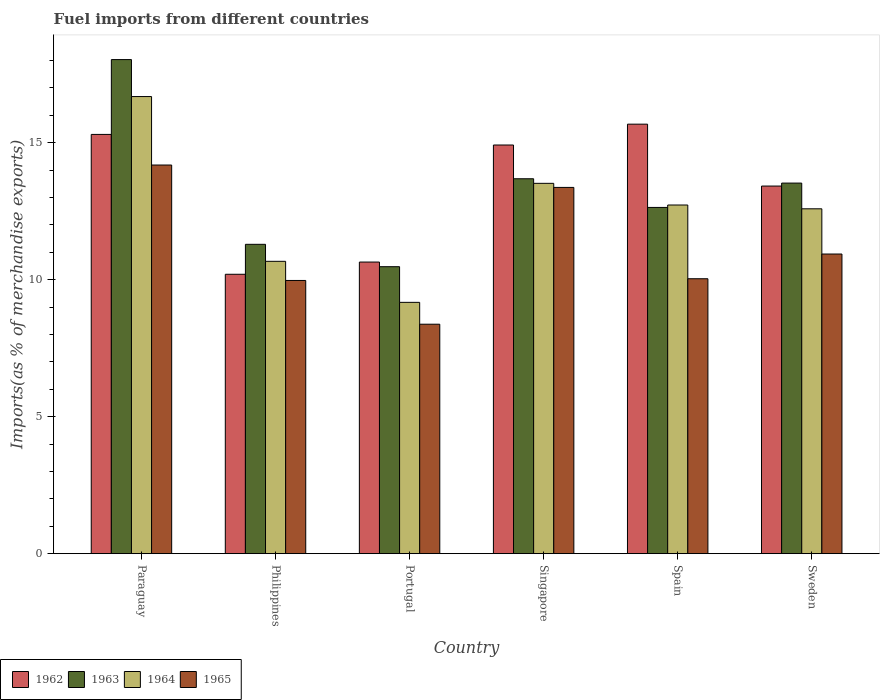How many different coloured bars are there?
Provide a succinct answer. 4. How many groups of bars are there?
Keep it short and to the point. 6. Are the number of bars per tick equal to the number of legend labels?
Provide a short and direct response. Yes. Are the number of bars on each tick of the X-axis equal?
Keep it short and to the point. Yes. How many bars are there on the 1st tick from the right?
Provide a short and direct response. 4. What is the percentage of imports to different countries in 1964 in Paraguay?
Your answer should be very brief. 16.68. Across all countries, what is the maximum percentage of imports to different countries in 1963?
Provide a succinct answer. 18.03. Across all countries, what is the minimum percentage of imports to different countries in 1964?
Provide a short and direct response. 9.17. What is the total percentage of imports to different countries in 1963 in the graph?
Ensure brevity in your answer.  79.63. What is the difference between the percentage of imports to different countries in 1962 in Spain and that in Sweden?
Provide a succinct answer. 2.26. What is the difference between the percentage of imports to different countries in 1962 in Sweden and the percentage of imports to different countries in 1964 in Portugal?
Make the answer very short. 4.24. What is the average percentage of imports to different countries in 1965 per country?
Your response must be concise. 11.14. What is the difference between the percentage of imports to different countries of/in 1962 and percentage of imports to different countries of/in 1965 in Spain?
Give a very brief answer. 5.64. In how many countries, is the percentage of imports to different countries in 1963 greater than 10 %?
Give a very brief answer. 6. What is the ratio of the percentage of imports to different countries in 1965 in Portugal to that in Spain?
Your response must be concise. 0.83. What is the difference between the highest and the second highest percentage of imports to different countries in 1965?
Offer a very short reply. -2.43. What is the difference between the highest and the lowest percentage of imports to different countries in 1962?
Ensure brevity in your answer.  5.48. In how many countries, is the percentage of imports to different countries in 1963 greater than the average percentage of imports to different countries in 1963 taken over all countries?
Keep it short and to the point. 3. Is the sum of the percentage of imports to different countries in 1964 in Paraguay and Philippines greater than the maximum percentage of imports to different countries in 1965 across all countries?
Your answer should be very brief. Yes. Is it the case that in every country, the sum of the percentage of imports to different countries in 1964 and percentage of imports to different countries in 1963 is greater than the sum of percentage of imports to different countries in 1965 and percentage of imports to different countries in 1962?
Give a very brief answer. No. What does the 4th bar from the left in Paraguay represents?
Offer a terse response. 1965. What does the 4th bar from the right in Paraguay represents?
Ensure brevity in your answer.  1962. Is it the case that in every country, the sum of the percentage of imports to different countries in 1963 and percentage of imports to different countries in 1965 is greater than the percentage of imports to different countries in 1964?
Your answer should be very brief. Yes. Are all the bars in the graph horizontal?
Give a very brief answer. No. How many countries are there in the graph?
Offer a terse response. 6. What is the difference between two consecutive major ticks on the Y-axis?
Provide a short and direct response. 5. Are the values on the major ticks of Y-axis written in scientific E-notation?
Provide a short and direct response. No. Does the graph contain any zero values?
Make the answer very short. No. Where does the legend appear in the graph?
Your response must be concise. Bottom left. What is the title of the graph?
Offer a terse response. Fuel imports from different countries. What is the label or title of the Y-axis?
Your response must be concise. Imports(as % of merchandise exports). What is the Imports(as % of merchandise exports) of 1962 in Paraguay?
Your answer should be compact. 15.3. What is the Imports(as % of merchandise exports) in 1963 in Paraguay?
Make the answer very short. 18.03. What is the Imports(as % of merchandise exports) in 1964 in Paraguay?
Your answer should be very brief. 16.68. What is the Imports(as % of merchandise exports) of 1965 in Paraguay?
Ensure brevity in your answer.  14.18. What is the Imports(as % of merchandise exports) in 1962 in Philippines?
Your response must be concise. 10.2. What is the Imports(as % of merchandise exports) of 1963 in Philippines?
Your answer should be very brief. 11.29. What is the Imports(as % of merchandise exports) of 1964 in Philippines?
Your answer should be compact. 10.67. What is the Imports(as % of merchandise exports) of 1965 in Philippines?
Make the answer very short. 9.97. What is the Imports(as % of merchandise exports) in 1962 in Portugal?
Ensure brevity in your answer.  10.64. What is the Imports(as % of merchandise exports) in 1963 in Portugal?
Offer a very short reply. 10.47. What is the Imports(as % of merchandise exports) of 1964 in Portugal?
Keep it short and to the point. 9.17. What is the Imports(as % of merchandise exports) in 1965 in Portugal?
Offer a very short reply. 8.37. What is the Imports(as % of merchandise exports) in 1962 in Singapore?
Provide a succinct answer. 14.91. What is the Imports(as % of merchandise exports) of 1963 in Singapore?
Provide a short and direct response. 13.68. What is the Imports(as % of merchandise exports) of 1964 in Singapore?
Your answer should be compact. 13.51. What is the Imports(as % of merchandise exports) of 1965 in Singapore?
Offer a terse response. 13.37. What is the Imports(as % of merchandise exports) in 1962 in Spain?
Your response must be concise. 15.67. What is the Imports(as % of merchandise exports) in 1963 in Spain?
Provide a short and direct response. 12.64. What is the Imports(as % of merchandise exports) of 1964 in Spain?
Your answer should be very brief. 12.72. What is the Imports(as % of merchandise exports) of 1965 in Spain?
Your answer should be compact. 10.03. What is the Imports(as % of merchandise exports) in 1962 in Sweden?
Keep it short and to the point. 13.42. What is the Imports(as % of merchandise exports) in 1963 in Sweden?
Make the answer very short. 13.52. What is the Imports(as % of merchandise exports) in 1964 in Sweden?
Offer a very short reply. 12.58. What is the Imports(as % of merchandise exports) of 1965 in Sweden?
Offer a very short reply. 10.93. Across all countries, what is the maximum Imports(as % of merchandise exports) of 1962?
Keep it short and to the point. 15.67. Across all countries, what is the maximum Imports(as % of merchandise exports) of 1963?
Your answer should be very brief. 18.03. Across all countries, what is the maximum Imports(as % of merchandise exports) in 1964?
Offer a terse response. 16.68. Across all countries, what is the maximum Imports(as % of merchandise exports) in 1965?
Offer a terse response. 14.18. Across all countries, what is the minimum Imports(as % of merchandise exports) in 1962?
Offer a very short reply. 10.2. Across all countries, what is the minimum Imports(as % of merchandise exports) of 1963?
Your answer should be very brief. 10.47. Across all countries, what is the minimum Imports(as % of merchandise exports) of 1964?
Your answer should be very brief. 9.17. Across all countries, what is the minimum Imports(as % of merchandise exports) in 1965?
Offer a very short reply. 8.37. What is the total Imports(as % of merchandise exports) of 1962 in the graph?
Your answer should be compact. 80.14. What is the total Imports(as % of merchandise exports) of 1963 in the graph?
Give a very brief answer. 79.63. What is the total Imports(as % of merchandise exports) of 1964 in the graph?
Provide a short and direct response. 75.34. What is the total Imports(as % of merchandise exports) in 1965 in the graph?
Your answer should be compact. 66.86. What is the difference between the Imports(as % of merchandise exports) in 1962 in Paraguay and that in Philippines?
Make the answer very short. 5.1. What is the difference between the Imports(as % of merchandise exports) in 1963 in Paraguay and that in Philippines?
Offer a very short reply. 6.74. What is the difference between the Imports(as % of merchandise exports) in 1964 in Paraguay and that in Philippines?
Your answer should be very brief. 6.01. What is the difference between the Imports(as % of merchandise exports) in 1965 in Paraguay and that in Philippines?
Your answer should be compact. 4.21. What is the difference between the Imports(as % of merchandise exports) of 1962 in Paraguay and that in Portugal?
Ensure brevity in your answer.  4.66. What is the difference between the Imports(as % of merchandise exports) in 1963 in Paraguay and that in Portugal?
Ensure brevity in your answer.  7.56. What is the difference between the Imports(as % of merchandise exports) in 1964 in Paraguay and that in Portugal?
Keep it short and to the point. 7.51. What is the difference between the Imports(as % of merchandise exports) in 1965 in Paraguay and that in Portugal?
Provide a succinct answer. 5.81. What is the difference between the Imports(as % of merchandise exports) in 1962 in Paraguay and that in Singapore?
Provide a succinct answer. 0.39. What is the difference between the Imports(as % of merchandise exports) in 1963 in Paraguay and that in Singapore?
Keep it short and to the point. 4.35. What is the difference between the Imports(as % of merchandise exports) of 1964 in Paraguay and that in Singapore?
Ensure brevity in your answer.  3.17. What is the difference between the Imports(as % of merchandise exports) in 1965 in Paraguay and that in Singapore?
Your answer should be compact. 0.82. What is the difference between the Imports(as % of merchandise exports) of 1962 in Paraguay and that in Spain?
Provide a short and direct response. -0.37. What is the difference between the Imports(as % of merchandise exports) of 1963 in Paraguay and that in Spain?
Ensure brevity in your answer.  5.4. What is the difference between the Imports(as % of merchandise exports) in 1964 in Paraguay and that in Spain?
Ensure brevity in your answer.  3.96. What is the difference between the Imports(as % of merchandise exports) in 1965 in Paraguay and that in Spain?
Give a very brief answer. 4.15. What is the difference between the Imports(as % of merchandise exports) of 1962 in Paraguay and that in Sweden?
Your response must be concise. 1.88. What is the difference between the Imports(as % of merchandise exports) in 1963 in Paraguay and that in Sweden?
Provide a succinct answer. 4.51. What is the difference between the Imports(as % of merchandise exports) of 1964 in Paraguay and that in Sweden?
Give a very brief answer. 4.1. What is the difference between the Imports(as % of merchandise exports) in 1965 in Paraguay and that in Sweden?
Provide a succinct answer. 3.25. What is the difference between the Imports(as % of merchandise exports) in 1962 in Philippines and that in Portugal?
Provide a succinct answer. -0.45. What is the difference between the Imports(as % of merchandise exports) in 1963 in Philippines and that in Portugal?
Provide a succinct answer. 0.82. What is the difference between the Imports(as % of merchandise exports) in 1964 in Philippines and that in Portugal?
Ensure brevity in your answer.  1.5. What is the difference between the Imports(as % of merchandise exports) in 1965 in Philippines and that in Portugal?
Provide a succinct answer. 1.6. What is the difference between the Imports(as % of merchandise exports) in 1962 in Philippines and that in Singapore?
Your answer should be very brief. -4.72. What is the difference between the Imports(as % of merchandise exports) in 1963 in Philippines and that in Singapore?
Make the answer very short. -2.39. What is the difference between the Imports(as % of merchandise exports) of 1964 in Philippines and that in Singapore?
Ensure brevity in your answer.  -2.85. What is the difference between the Imports(as % of merchandise exports) of 1965 in Philippines and that in Singapore?
Ensure brevity in your answer.  -3.4. What is the difference between the Imports(as % of merchandise exports) in 1962 in Philippines and that in Spain?
Provide a short and direct response. -5.48. What is the difference between the Imports(as % of merchandise exports) in 1963 in Philippines and that in Spain?
Ensure brevity in your answer.  -1.35. What is the difference between the Imports(as % of merchandise exports) of 1964 in Philippines and that in Spain?
Your response must be concise. -2.05. What is the difference between the Imports(as % of merchandise exports) of 1965 in Philippines and that in Spain?
Keep it short and to the point. -0.06. What is the difference between the Imports(as % of merchandise exports) of 1962 in Philippines and that in Sweden?
Make the answer very short. -3.22. What is the difference between the Imports(as % of merchandise exports) in 1963 in Philippines and that in Sweden?
Offer a terse response. -2.23. What is the difference between the Imports(as % of merchandise exports) of 1964 in Philippines and that in Sweden?
Give a very brief answer. -1.92. What is the difference between the Imports(as % of merchandise exports) in 1965 in Philippines and that in Sweden?
Provide a short and direct response. -0.96. What is the difference between the Imports(as % of merchandise exports) in 1962 in Portugal and that in Singapore?
Make the answer very short. -4.27. What is the difference between the Imports(as % of merchandise exports) of 1963 in Portugal and that in Singapore?
Your answer should be very brief. -3.21. What is the difference between the Imports(as % of merchandise exports) of 1964 in Portugal and that in Singapore?
Your answer should be compact. -4.34. What is the difference between the Imports(as % of merchandise exports) of 1965 in Portugal and that in Singapore?
Your answer should be compact. -4.99. What is the difference between the Imports(as % of merchandise exports) of 1962 in Portugal and that in Spain?
Your answer should be very brief. -5.03. What is the difference between the Imports(as % of merchandise exports) of 1963 in Portugal and that in Spain?
Provide a short and direct response. -2.16. What is the difference between the Imports(as % of merchandise exports) of 1964 in Portugal and that in Spain?
Offer a terse response. -3.55. What is the difference between the Imports(as % of merchandise exports) in 1965 in Portugal and that in Spain?
Your answer should be very brief. -1.66. What is the difference between the Imports(as % of merchandise exports) of 1962 in Portugal and that in Sweden?
Offer a terse response. -2.77. What is the difference between the Imports(as % of merchandise exports) in 1963 in Portugal and that in Sweden?
Offer a terse response. -3.05. What is the difference between the Imports(as % of merchandise exports) in 1964 in Portugal and that in Sweden?
Provide a succinct answer. -3.41. What is the difference between the Imports(as % of merchandise exports) in 1965 in Portugal and that in Sweden?
Your answer should be very brief. -2.56. What is the difference between the Imports(as % of merchandise exports) in 1962 in Singapore and that in Spain?
Your answer should be compact. -0.76. What is the difference between the Imports(as % of merchandise exports) in 1963 in Singapore and that in Spain?
Give a very brief answer. 1.05. What is the difference between the Imports(as % of merchandise exports) in 1964 in Singapore and that in Spain?
Offer a terse response. 0.79. What is the difference between the Imports(as % of merchandise exports) in 1965 in Singapore and that in Spain?
Your answer should be very brief. 3.33. What is the difference between the Imports(as % of merchandise exports) of 1962 in Singapore and that in Sweden?
Offer a terse response. 1.5. What is the difference between the Imports(as % of merchandise exports) in 1963 in Singapore and that in Sweden?
Provide a succinct answer. 0.16. What is the difference between the Imports(as % of merchandise exports) in 1964 in Singapore and that in Sweden?
Ensure brevity in your answer.  0.93. What is the difference between the Imports(as % of merchandise exports) in 1965 in Singapore and that in Sweden?
Offer a very short reply. 2.43. What is the difference between the Imports(as % of merchandise exports) of 1962 in Spain and that in Sweden?
Provide a short and direct response. 2.26. What is the difference between the Imports(as % of merchandise exports) in 1963 in Spain and that in Sweden?
Provide a short and direct response. -0.89. What is the difference between the Imports(as % of merchandise exports) in 1964 in Spain and that in Sweden?
Ensure brevity in your answer.  0.14. What is the difference between the Imports(as % of merchandise exports) in 1965 in Spain and that in Sweden?
Make the answer very short. -0.9. What is the difference between the Imports(as % of merchandise exports) of 1962 in Paraguay and the Imports(as % of merchandise exports) of 1963 in Philippines?
Provide a succinct answer. 4.01. What is the difference between the Imports(as % of merchandise exports) of 1962 in Paraguay and the Imports(as % of merchandise exports) of 1964 in Philippines?
Give a very brief answer. 4.63. What is the difference between the Imports(as % of merchandise exports) in 1962 in Paraguay and the Imports(as % of merchandise exports) in 1965 in Philippines?
Make the answer very short. 5.33. What is the difference between the Imports(as % of merchandise exports) of 1963 in Paraguay and the Imports(as % of merchandise exports) of 1964 in Philippines?
Provide a short and direct response. 7.36. What is the difference between the Imports(as % of merchandise exports) of 1963 in Paraguay and the Imports(as % of merchandise exports) of 1965 in Philippines?
Offer a terse response. 8.06. What is the difference between the Imports(as % of merchandise exports) in 1964 in Paraguay and the Imports(as % of merchandise exports) in 1965 in Philippines?
Ensure brevity in your answer.  6.71. What is the difference between the Imports(as % of merchandise exports) of 1962 in Paraguay and the Imports(as % of merchandise exports) of 1963 in Portugal?
Give a very brief answer. 4.83. What is the difference between the Imports(as % of merchandise exports) in 1962 in Paraguay and the Imports(as % of merchandise exports) in 1964 in Portugal?
Provide a short and direct response. 6.13. What is the difference between the Imports(as % of merchandise exports) in 1962 in Paraguay and the Imports(as % of merchandise exports) in 1965 in Portugal?
Ensure brevity in your answer.  6.93. What is the difference between the Imports(as % of merchandise exports) of 1963 in Paraguay and the Imports(as % of merchandise exports) of 1964 in Portugal?
Your answer should be very brief. 8.86. What is the difference between the Imports(as % of merchandise exports) of 1963 in Paraguay and the Imports(as % of merchandise exports) of 1965 in Portugal?
Your answer should be compact. 9.66. What is the difference between the Imports(as % of merchandise exports) of 1964 in Paraguay and the Imports(as % of merchandise exports) of 1965 in Portugal?
Your response must be concise. 8.31. What is the difference between the Imports(as % of merchandise exports) in 1962 in Paraguay and the Imports(as % of merchandise exports) in 1963 in Singapore?
Provide a short and direct response. 1.62. What is the difference between the Imports(as % of merchandise exports) of 1962 in Paraguay and the Imports(as % of merchandise exports) of 1964 in Singapore?
Give a very brief answer. 1.79. What is the difference between the Imports(as % of merchandise exports) of 1962 in Paraguay and the Imports(as % of merchandise exports) of 1965 in Singapore?
Make the answer very short. 1.93. What is the difference between the Imports(as % of merchandise exports) in 1963 in Paraguay and the Imports(as % of merchandise exports) in 1964 in Singapore?
Provide a succinct answer. 4.52. What is the difference between the Imports(as % of merchandise exports) of 1963 in Paraguay and the Imports(as % of merchandise exports) of 1965 in Singapore?
Keep it short and to the point. 4.67. What is the difference between the Imports(as % of merchandise exports) of 1964 in Paraguay and the Imports(as % of merchandise exports) of 1965 in Singapore?
Your response must be concise. 3.32. What is the difference between the Imports(as % of merchandise exports) in 1962 in Paraguay and the Imports(as % of merchandise exports) in 1963 in Spain?
Offer a terse response. 2.66. What is the difference between the Imports(as % of merchandise exports) of 1962 in Paraguay and the Imports(as % of merchandise exports) of 1964 in Spain?
Offer a terse response. 2.58. What is the difference between the Imports(as % of merchandise exports) of 1962 in Paraguay and the Imports(as % of merchandise exports) of 1965 in Spain?
Offer a terse response. 5.27. What is the difference between the Imports(as % of merchandise exports) of 1963 in Paraguay and the Imports(as % of merchandise exports) of 1964 in Spain?
Give a very brief answer. 5.31. What is the difference between the Imports(as % of merchandise exports) of 1963 in Paraguay and the Imports(as % of merchandise exports) of 1965 in Spain?
Keep it short and to the point. 8. What is the difference between the Imports(as % of merchandise exports) in 1964 in Paraguay and the Imports(as % of merchandise exports) in 1965 in Spain?
Offer a very short reply. 6.65. What is the difference between the Imports(as % of merchandise exports) of 1962 in Paraguay and the Imports(as % of merchandise exports) of 1963 in Sweden?
Your response must be concise. 1.78. What is the difference between the Imports(as % of merchandise exports) in 1962 in Paraguay and the Imports(as % of merchandise exports) in 1964 in Sweden?
Your response must be concise. 2.71. What is the difference between the Imports(as % of merchandise exports) of 1962 in Paraguay and the Imports(as % of merchandise exports) of 1965 in Sweden?
Your answer should be compact. 4.36. What is the difference between the Imports(as % of merchandise exports) in 1963 in Paraguay and the Imports(as % of merchandise exports) in 1964 in Sweden?
Give a very brief answer. 5.45. What is the difference between the Imports(as % of merchandise exports) of 1963 in Paraguay and the Imports(as % of merchandise exports) of 1965 in Sweden?
Your answer should be compact. 7.1. What is the difference between the Imports(as % of merchandise exports) of 1964 in Paraguay and the Imports(as % of merchandise exports) of 1965 in Sweden?
Keep it short and to the point. 5.75. What is the difference between the Imports(as % of merchandise exports) in 1962 in Philippines and the Imports(as % of merchandise exports) in 1963 in Portugal?
Keep it short and to the point. -0.28. What is the difference between the Imports(as % of merchandise exports) of 1962 in Philippines and the Imports(as % of merchandise exports) of 1964 in Portugal?
Your answer should be compact. 1.03. What is the difference between the Imports(as % of merchandise exports) in 1962 in Philippines and the Imports(as % of merchandise exports) in 1965 in Portugal?
Offer a terse response. 1.82. What is the difference between the Imports(as % of merchandise exports) in 1963 in Philippines and the Imports(as % of merchandise exports) in 1964 in Portugal?
Make the answer very short. 2.12. What is the difference between the Imports(as % of merchandise exports) in 1963 in Philippines and the Imports(as % of merchandise exports) in 1965 in Portugal?
Offer a very short reply. 2.92. What is the difference between the Imports(as % of merchandise exports) of 1964 in Philippines and the Imports(as % of merchandise exports) of 1965 in Portugal?
Give a very brief answer. 2.3. What is the difference between the Imports(as % of merchandise exports) of 1962 in Philippines and the Imports(as % of merchandise exports) of 1963 in Singapore?
Provide a succinct answer. -3.49. What is the difference between the Imports(as % of merchandise exports) of 1962 in Philippines and the Imports(as % of merchandise exports) of 1964 in Singapore?
Offer a terse response. -3.32. What is the difference between the Imports(as % of merchandise exports) in 1962 in Philippines and the Imports(as % of merchandise exports) in 1965 in Singapore?
Make the answer very short. -3.17. What is the difference between the Imports(as % of merchandise exports) in 1963 in Philippines and the Imports(as % of merchandise exports) in 1964 in Singapore?
Keep it short and to the point. -2.23. What is the difference between the Imports(as % of merchandise exports) in 1963 in Philippines and the Imports(as % of merchandise exports) in 1965 in Singapore?
Your response must be concise. -2.08. What is the difference between the Imports(as % of merchandise exports) in 1964 in Philippines and the Imports(as % of merchandise exports) in 1965 in Singapore?
Offer a very short reply. -2.7. What is the difference between the Imports(as % of merchandise exports) of 1962 in Philippines and the Imports(as % of merchandise exports) of 1963 in Spain?
Provide a succinct answer. -2.44. What is the difference between the Imports(as % of merchandise exports) of 1962 in Philippines and the Imports(as % of merchandise exports) of 1964 in Spain?
Provide a short and direct response. -2.53. What is the difference between the Imports(as % of merchandise exports) of 1962 in Philippines and the Imports(as % of merchandise exports) of 1965 in Spain?
Give a very brief answer. 0.16. What is the difference between the Imports(as % of merchandise exports) in 1963 in Philippines and the Imports(as % of merchandise exports) in 1964 in Spain?
Offer a terse response. -1.43. What is the difference between the Imports(as % of merchandise exports) of 1963 in Philippines and the Imports(as % of merchandise exports) of 1965 in Spain?
Ensure brevity in your answer.  1.26. What is the difference between the Imports(as % of merchandise exports) of 1964 in Philippines and the Imports(as % of merchandise exports) of 1965 in Spain?
Ensure brevity in your answer.  0.64. What is the difference between the Imports(as % of merchandise exports) of 1962 in Philippines and the Imports(as % of merchandise exports) of 1963 in Sweden?
Provide a short and direct response. -3.33. What is the difference between the Imports(as % of merchandise exports) of 1962 in Philippines and the Imports(as % of merchandise exports) of 1964 in Sweden?
Ensure brevity in your answer.  -2.39. What is the difference between the Imports(as % of merchandise exports) in 1962 in Philippines and the Imports(as % of merchandise exports) in 1965 in Sweden?
Your response must be concise. -0.74. What is the difference between the Imports(as % of merchandise exports) of 1963 in Philippines and the Imports(as % of merchandise exports) of 1964 in Sweden?
Ensure brevity in your answer.  -1.3. What is the difference between the Imports(as % of merchandise exports) of 1963 in Philippines and the Imports(as % of merchandise exports) of 1965 in Sweden?
Your answer should be compact. 0.35. What is the difference between the Imports(as % of merchandise exports) of 1964 in Philippines and the Imports(as % of merchandise exports) of 1965 in Sweden?
Ensure brevity in your answer.  -0.27. What is the difference between the Imports(as % of merchandise exports) in 1962 in Portugal and the Imports(as % of merchandise exports) in 1963 in Singapore?
Your answer should be very brief. -3.04. What is the difference between the Imports(as % of merchandise exports) in 1962 in Portugal and the Imports(as % of merchandise exports) in 1964 in Singapore?
Give a very brief answer. -2.87. What is the difference between the Imports(as % of merchandise exports) in 1962 in Portugal and the Imports(as % of merchandise exports) in 1965 in Singapore?
Keep it short and to the point. -2.72. What is the difference between the Imports(as % of merchandise exports) in 1963 in Portugal and the Imports(as % of merchandise exports) in 1964 in Singapore?
Make the answer very short. -3.04. What is the difference between the Imports(as % of merchandise exports) in 1963 in Portugal and the Imports(as % of merchandise exports) in 1965 in Singapore?
Your answer should be very brief. -2.89. What is the difference between the Imports(as % of merchandise exports) in 1964 in Portugal and the Imports(as % of merchandise exports) in 1965 in Singapore?
Provide a succinct answer. -4.19. What is the difference between the Imports(as % of merchandise exports) in 1962 in Portugal and the Imports(as % of merchandise exports) in 1963 in Spain?
Your response must be concise. -1.99. What is the difference between the Imports(as % of merchandise exports) of 1962 in Portugal and the Imports(as % of merchandise exports) of 1964 in Spain?
Keep it short and to the point. -2.08. What is the difference between the Imports(as % of merchandise exports) in 1962 in Portugal and the Imports(as % of merchandise exports) in 1965 in Spain?
Offer a very short reply. 0.61. What is the difference between the Imports(as % of merchandise exports) in 1963 in Portugal and the Imports(as % of merchandise exports) in 1964 in Spain?
Provide a short and direct response. -2.25. What is the difference between the Imports(as % of merchandise exports) of 1963 in Portugal and the Imports(as % of merchandise exports) of 1965 in Spain?
Offer a very short reply. 0.44. What is the difference between the Imports(as % of merchandise exports) in 1964 in Portugal and the Imports(as % of merchandise exports) in 1965 in Spain?
Ensure brevity in your answer.  -0.86. What is the difference between the Imports(as % of merchandise exports) in 1962 in Portugal and the Imports(as % of merchandise exports) in 1963 in Sweden?
Keep it short and to the point. -2.88. What is the difference between the Imports(as % of merchandise exports) of 1962 in Portugal and the Imports(as % of merchandise exports) of 1964 in Sweden?
Make the answer very short. -1.94. What is the difference between the Imports(as % of merchandise exports) of 1962 in Portugal and the Imports(as % of merchandise exports) of 1965 in Sweden?
Offer a terse response. -0.29. What is the difference between the Imports(as % of merchandise exports) in 1963 in Portugal and the Imports(as % of merchandise exports) in 1964 in Sweden?
Provide a succinct answer. -2.11. What is the difference between the Imports(as % of merchandise exports) in 1963 in Portugal and the Imports(as % of merchandise exports) in 1965 in Sweden?
Your answer should be very brief. -0.46. What is the difference between the Imports(as % of merchandise exports) in 1964 in Portugal and the Imports(as % of merchandise exports) in 1965 in Sweden?
Provide a succinct answer. -1.76. What is the difference between the Imports(as % of merchandise exports) in 1962 in Singapore and the Imports(as % of merchandise exports) in 1963 in Spain?
Give a very brief answer. 2.28. What is the difference between the Imports(as % of merchandise exports) in 1962 in Singapore and the Imports(as % of merchandise exports) in 1964 in Spain?
Provide a short and direct response. 2.19. What is the difference between the Imports(as % of merchandise exports) in 1962 in Singapore and the Imports(as % of merchandise exports) in 1965 in Spain?
Your answer should be very brief. 4.88. What is the difference between the Imports(as % of merchandise exports) in 1963 in Singapore and the Imports(as % of merchandise exports) in 1964 in Spain?
Provide a short and direct response. 0.96. What is the difference between the Imports(as % of merchandise exports) in 1963 in Singapore and the Imports(as % of merchandise exports) in 1965 in Spain?
Offer a very short reply. 3.65. What is the difference between the Imports(as % of merchandise exports) in 1964 in Singapore and the Imports(as % of merchandise exports) in 1965 in Spain?
Make the answer very short. 3.48. What is the difference between the Imports(as % of merchandise exports) in 1962 in Singapore and the Imports(as % of merchandise exports) in 1963 in Sweden?
Provide a succinct answer. 1.39. What is the difference between the Imports(as % of merchandise exports) in 1962 in Singapore and the Imports(as % of merchandise exports) in 1964 in Sweden?
Make the answer very short. 2.33. What is the difference between the Imports(as % of merchandise exports) in 1962 in Singapore and the Imports(as % of merchandise exports) in 1965 in Sweden?
Keep it short and to the point. 3.98. What is the difference between the Imports(as % of merchandise exports) of 1963 in Singapore and the Imports(as % of merchandise exports) of 1964 in Sweden?
Provide a short and direct response. 1.1. What is the difference between the Imports(as % of merchandise exports) in 1963 in Singapore and the Imports(as % of merchandise exports) in 1965 in Sweden?
Offer a terse response. 2.75. What is the difference between the Imports(as % of merchandise exports) in 1964 in Singapore and the Imports(as % of merchandise exports) in 1965 in Sweden?
Ensure brevity in your answer.  2.58. What is the difference between the Imports(as % of merchandise exports) in 1962 in Spain and the Imports(as % of merchandise exports) in 1963 in Sweden?
Make the answer very short. 2.15. What is the difference between the Imports(as % of merchandise exports) of 1962 in Spain and the Imports(as % of merchandise exports) of 1964 in Sweden?
Offer a very short reply. 3.09. What is the difference between the Imports(as % of merchandise exports) of 1962 in Spain and the Imports(as % of merchandise exports) of 1965 in Sweden?
Provide a succinct answer. 4.74. What is the difference between the Imports(as % of merchandise exports) of 1963 in Spain and the Imports(as % of merchandise exports) of 1964 in Sweden?
Your response must be concise. 0.05. What is the difference between the Imports(as % of merchandise exports) of 1963 in Spain and the Imports(as % of merchandise exports) of 1965 in Sweden?
Give a very brief answer. 1.7. What is the difference between the Imports(as % of merchandise exports) of 1964 in Spain and the Imports(as % of merchandise exports) of 1965 in Sweden?
Offer a terse response. 1.79. What is the average Imports(as % of merchandise exports) of 1962 per country?
Provide a succinct answer. 13.36. What is the average Imports(as % of merchandise exports) of 1963 per country?
Your answer should be compact. 13.27. What is the average Imports(as % of merchandise exports) of 1964 per country?
Your answer should be very brief. 12.56. What is the average Imports(as % of merchandise exports) in 1965 per country?
Your answer should be very brief. 11.14. What is the difference between the Imports(as % of merchandise exports) in 1962 and Imports(as % of merchandise exports) in 1963 in Paraguay?
Your answer should be very brief. -2.73. What is the difference between the Imports(as % of merchandise exports) of 1962 and Imports(as % of merchandise exports) of 1964 in Paraguay?
Your answer should be very brief. -1.38. What is the difference between the Imports(as % of merchandise exports) of 1962 and Imports(as % of merchandise exports) of 1965 in Paraguay?
Ensure brevity in your answer.  1.12. What is the difference between the Imports(as % of merchandise exports) in 1963 and Imports(as % of merchandise exports) in 1964 in Paraguay?
Offer a terse response. 1.35. What is the difference between the Imports(as % of merchandise exports) of 1963 and Imports(as % of merchandise exports) of 1965 in Paraguay?
Make the answer very short. 3.85. What is the difference between the Imports(as % of merchandise exports) of 1964 and Imports(as % of merchandise exports) of 1965 in Paraguay?
Make the answer very short. 2.5. What is the difference between the Imports(as % of merchandise exports) of 1962 and Imports(as % of merchandise exports) of 1963 in Philippines?
Provide a succinct answer. -1.09. What is the difference between the Imports(as % of merchandise exports) of 1962 and Imports(as % of merchandise exports) of 1964 in Philippines?
Keep it short and to the point. -0.47. What is the difference between the Imports(as % of merchandise exports) in 1962 and Imports(as % of merchandise exports) in 1965 in Philippines?
Provide a short and direct response. 0.23. What is the difference between the Imports(as % of merchandise exports) of 1963 and Imports(as % of merchandise exports) of 1964 in Philippines?
Offer a very short reply. 0.62. What is the difference between the Imports(as % of merchandise exports) of 1963 and Imports(as % of merchandise exports) of 1965 in Philippines?
Your answer should be compact. 1.32. What is the difference between the Imports(as % of merchandise exports) of 1964 and Imports(as % of merchandise exports) of 1965 in Philippines?
Offer a very short reply. 0.7. What is the difference between the Imports(as % of merchandise exports) in 1962 and Imports(as % of merchandise exports) in 1963 in Portugal?
Your answer should be very brief. 0.17. What is the difference between the Imports(as % of merchandise exports) of 1962 and Imports(as % of merchandise exports) of 1964 in Portugal?
Keep it short and to the point. 1.47. What is the difference between the Imports(as % of merchandise exports) in 1962 and Imports(as % of merchandise exports) in 1965 in Portugal?
Your answer should be compact. 2.27. What is the difference between the Imports(as % of merchandise exports) in 1963 and Imports(as % of merchandise exports) in 1964 in Portugal?
Offer a very short reply. 1.3. What is the difference between the Imports(as % of merchandise exports) in 1963 and Imports(as % of merchandise exports) in 1965 in Portugal?
Make the answer very short. 2.1. What is the difference between the Imports(as % of merchandise exports) of 1964 and Imports(as % of merchandise exports) of 1965 in Portugal?
Your answer should be very brief. 0.8. What is the difference between the Imports(as % of merchandise exports) in 1962 and Imports(as % of merchandise exports) in 1963 in Singapore?
Provide a succinct answer. 1.23. What is the difference between the Imports(as % of merchandise exports) in 1962 and Imports(as % of merchandise exports) in 1964 in Singapore?
Provide a succinct answer. 1.4. What is the difference between the Imports(as % of merchandise exports) in 1962 and Imports(as % of merchandise exports) in 1965 in Singapore?
Give a very brief answer. 1.55. What is the difference between the Imports(as % of merchandise exports) of 1963 and Imports(as % of merchandise exports) of 1964 in Singapore?
Keep it short and to the point. 0.17. What is the difference between the Imports(as % of merchandise exports) of 1963 and Imports(as % of merchandise exports) of 1965 in Singapore?
Offer a terse response. 0.32. What is the difference between the Imports(as % of merchandise exports) of 1964 and Imports(as % of merchandise exports) of 1965 in Singapore?
Your answer should be very brief. 0.15. What is the difference between the Imports(as % of merchandise exports) in 1962 and Imports(as % of merchandise exports) in 1963 in Spain?
Provide a short and direct response. 3.04. What is the difference between the Imports(as % of merchandise exports) in 1962 and Imports(as % of merchandise exports) in 1964 in Spain?
Make the answer very short. 2.95. What is the difference between the Imports(as % of merchandise exports) of 1962 and Imports(as % of merchandise exports) of 1965 in Spain?
Your answer should be compact. 5.64. What is the difference between the Imports(as % of merchandise exports) of 1963 and Imports(as % of merchandise exports) of 1964 in Spain?
Give a very brief answer. -0.09. What is the difference between the Imports(as % of merchandise exports) of 1963 and Imports(as % of merchandise exports) of 1965 in Spain?
Keep it short and to the point. 2.6. What is the difference between the Imports(as % of merchandise exports) in 1964 and Imports(as % of merchandise exports) in 1965 in Spain?
Your answer should be compact. 2.69. What is the difference between the Imports(as % of merchandise exports) in 1962 and Imports(as % of merchandise exports) in 1963 in Sweden?
Provide a short and direct response. -0.11. What is the difference between the Imports(as % of merchandise exports) in 1962 and Imports(as % of merchandise exports) in 1964 in Sweden?
Offer a terse response. 0.83. What is the difference between the Imports(as % of merchandise exports) in 1962 and Imports(as % of merchandise exports) in 1965 in Sweden?
Ensure brevity in your answer.  2.48. What is the difference between the Imports(as % of merchandise exports) of 1963 and Imports(as % of merchandise exports) of 1964 in Sweden?
Your response must be concise. 0.94. What is the difference between the Imports(as % of merchandise exports) in 1963 and Imports(as % of merchandise exports) in 1965 in Sweden?
Give a very brief answer. 2.59. What is the difference between the Imports(as % of merchandise exports) of 1964 and Imports(as % of merchandise exports) of 1965 in Sweden?
Ensure brevity in your answer.  1.65. What is the ratio of the Imports(as % of merchandise exports) of 1962 in Paraguay to that in Philippines?
Provide a succinct answer. 1.5. What is the ratio of the Imports(as % of merchandise exports) of 1963 in Paraguay to that in Philippines?
Provide a short and direct response. 1.6. What is the ratio of the Imports(as % of merchandise exports) of 1964 in Paraguay to that in Philippines?
Provide a short and direct response. 1.56. What is the ratio of the Imports(as % of merchandise exports) in 1965 in Paraguay to that in Philippines?
Make the answer very short. 1.42. What is the ratio of the Imports(as % of merchandise exports) in 1962 in Paraguay to that in Portugal?
Give a very brief answer. 1.44. What is the ratio of the Imports(as % of merchandise exports) in 1963 in Paraguay to that in Portugal?
Offer a terse response. 1.72. What is the ratio of the Imports(as % of merchandise exports) in 1964 in Paraguay to that in Portugal?
Your answer should be very brief. 1.82. What is the ratio of the Imports(as % of merchandise exports) in 1965 in Paraguay to that in Portugal?
Provide a short and direct response. 1.69. What is the ratio of the Imports(as % of merchandise exports) in 1962 in Paraguay to that in Singapore?
Your answer should be compact. 1.03. What is the ratio of the Imports(as % of merchandise exports) of 1963 in Paraguay to that in Singapore?
Your answer should be very brief. 1.32. What is the ratio of the Imports(as % of merchandise exports) in 1964 in Paraguay to that in Singapore?
Offer a very short reply. 1.23. What is the ratio of the Imports(as % of merchandise exports) of 1965 in Paraguay to that in Singapore?
Keep it short and to the point. 1.06. What is the ratio of the Imports(as % of merchandise exports) of 1962 in Paraguay to that in Spain?
Provide a short and direct response. 0.98. What is the ratio of the Imports(as % of merchandise exports) of 1963 in Paraguay to that in Spain?
Offer a terse response. 1.43. What is the ratio of the Imports(as % of merchandise exports) in 1964 in Paraguay to that in Spain?
Keep it short and to the point. 1.31. What is the ratio of the Imports(as % of merchandise exports) of 1965 in Paraguay to that in Spain?
Make the answer very short. 1.41. What is the ratio of the Imports(as % of merchandise exports) of 1962 in Paraguay to that in Sweden?
Keep it short and to the point. 1.14. What is the ratio of the Imports(as % of merchandise exports) in 1964 in Paraguay to that in Sweden?
Your answer should be very brief. 1.33. What is the ratio of the Imports(as % of merchandise exports) in 1965 in Paraguay to that in Sweden?
Ensure brevity in your answer.  1.3. What is the ratio of the Imports(as % of merchandise exports) of 1962 in Philippines to that in Portugal?
Offer a terse response. 0.96. What is the ratio of the Imports(as % of merchandise exports) of 1963 in Philippines to that in Portugal?
Offer a very short reply. 1.08. What is the ratio of the Imports(as % of merchandise exports) in 1964 in Philippines to that in Portugal?
Your response must be concise. 1.16. What is the ratio of the Imports(as % of merchandise exports) in 1965 in Philippines to that in Portugal?
Your response must be concise. 1.19. What is the ratio of the Imports(as % of merchandise exports) of 1962 in Philippines to that in Singapore?
Offer a terse response. 0.68. What is the ratio of the Imports(as % of merchandise exports) in 1963 in Philippines to that in Singapore?
Offer a terse response. 0.83. What is the ratio of the Imports(as % of merchandise exports) of 1964 in Philippines to that in Singapore?
Your answer should be very brief. 0.79. What is the ratio of the Imports(as % of merchandise exports) in 1965 in Philippines to that in Singapore?
Your answer should be compact. 0.75. What is the ratio of the Imports(as % of merchandise exports) in 1962 in Philippines to that in Spain?
Your response must be concise. 0.65. What is the ratio of the Imports(as % of merchandise exports) in 1963 in Philippines to that in Spain?
Ensure brevity in your answer.  0.89. What is the ratio of the Imports(as % of merchandise exports) of 1964 in Philippines to that in Spain?
Ensure brevity in your answer.  0.84. What is the ratio of the Imports(as % of merchandise exports) in 1965 in Philippines to that in Spain?
Offer a very short reply. 0.99. What is the ratio of the Imports(as % of merchandise exports) in 1962 in Philippines to that in Sweden?
Offer a very short reply. 0.76. What is the ratio of the Imports(as % of merchandise exports) in 1963 in Philippines to that in Sweden?
Your answer should be compact. 0.83. What is the ratio of the Imports(as % of merchandise exports) of 1964 in Philippines to that in Sweden?
Ensure brevity in your answer.  0.85. What is the ratio of the Imports(as % of merchandise exports) in 1965 in Philippines to that in Sweden?
Make the answer very short. 0.91. What is the ratio of the Imports(as % of merchandise exports) of 1962 in Portugal to that in Singapore?
Offer a very short reply. 0.71. What is the ratio of the Imports(as % of merchandise exports) in 1963 in Portugal to that in Singapore?
Keep it short and to the point. 0.77. What is the ratio of the Imports(as % of merchandise exports) in 1964 in Portugal to that in Singapore?
Your response must be concise. 0.68. What is the ratio of the Imports(as % of merchandise exports) of 1965 in Portugal to that in Singapore?
Make the answer very short. 0.63. What is the ratio of the Imports(as % of merchandise exports) of 1962 in Portugal to that in Spain?
Provide a succinct answer. 0.68. What is the ratio of the Imports(as % of merchandise exports) in 1963 in Portugal to that in Spain?
Keep it short and to the point. 0.83. What is the ratio of the Imports(as % of merchandise exports) in 1964 in Portugal to that in Spain?
Provide a short and direct response. 0.72. What is the ratio of the Imports(as % of merchandise exports) of 1965 in Portugal to that in Spain?
Keep it short and to the point. 0.83. What is the ratio of the Imports(as % of merchandise exports) in 1962 in Portugal to that in Sweden?
Your answer should be compact. 0.79. What is the ratio of the Imports(as % of merchandise exports) of 1963 in Portugal to that in Sweden?
Make the answer very short. 0.77. What is the ratio of the Imports(as % of merchandise exports) of 1964 in Portugal to that in Sweden?
Give a very brief answer. 0.73. What is the ratio of the Imports(as % of merchandise exports) in 1965 in Portugal to that in Sweden?
Give a very brief answer. 0.77. What is the ratio of the Imports(as % of merchandise exports) in 1962 in Singapore to that in Spain?
Provide a succinct answer. 0.95. What is the ratio of the Imports(as % of merchandise exports) in 1963 in Singapore to that in Spain?
Give a very brief answer. 1.08. What is the ratio of the Imports(as % of merchandise exports) of 1964 in Singapore to that in Spain?
Ensure brevity in your answer.  1.06. What is the ratio of the Imports(as % of merchandise exports) in 1965 in Singapore to that in Spain?
Your answer should be very brief. 1.33. What is the ratio of the Imports(as % of merchandise exports) of 1962 in Singapore to that in Sweden?
Make the answer very short. 1.11. What is the ratio of the Imports(as % of merchandise exports) of 1963 in Singapore to that in Sweden?
Give a very brief answer. 1.01. What is the ratio of the Imports(as % of merchandise exports) of 1964 in Singapore to that in Sweden?
Offer a very short reply. 1.07. What is the ratio of the Imports(as % of merchandise exports) of 1965 in Singapore to that in Sweden?
Your answer should be very brief. 1.22. What is the ratio of the Imports(as % of merchandise exports) of 1962 in Spain to that in Sweden?
Ensure brevity in your answer.  1.17. What is the ratio of the Imports(as % of merchandise exports) of 1963 in Spain to that in Sweden?
Keep it short and to the point. 0.93. What is the ratio of the Imports(as % of merchandise exports) in 1965 in Spain to that in Sweden?
Ensure brevity in your answer.  0.92. What is the difference between the highest and the second highest Imports(as % of merchandise exports) of 1962?
Offer a very short reply. 0.37. What is the difference between the highest and the second highest Imports(as % of merchandise exports) in 1963?
Offer a terse response. 4.35. What is the difference between the highest and the second highest Imports(as % of merchandise exports) of 1964?
Offer a terse response. 3.17. What is the difference between the highest and the second highest Imports(as % of merchandise exports) of 1965?
Offer a terse response. 0.82. What is the difference between the highest and the lowest Imports(as % of merchandise exports) of 1962?
Keep it short and to the point. 5.48. What is the difference between the highest and the lowest Imports(as % of merchandise exports) in 1963?
Offer a terse response. 7.56. What is the difference between the highest and the lowest Imports(as % of merchandise exports) in 1964?
Ensure brevity in your answer.  7.51. What is the difference between the highest and the lowest Imports(as % of merchandise exports) in 1965?
Ensure brevity in your answer.  5.81. 